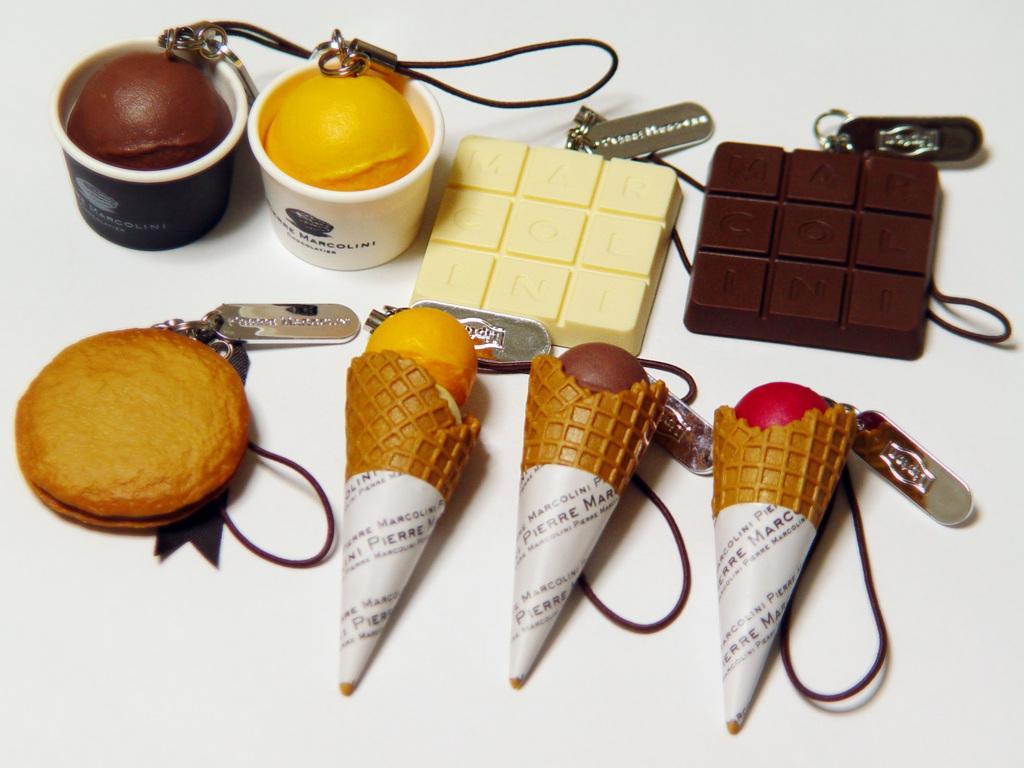Can you describe this image briefly? In this image I can see few depictions of ice cream and chocolates. I can also see something is written on few stuffs. 